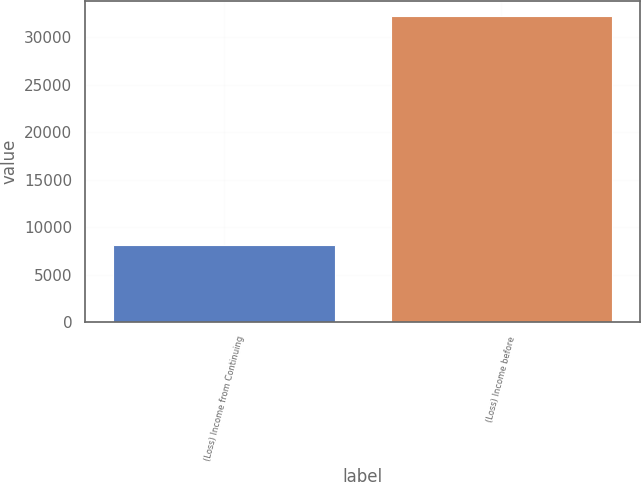Convert chart to OTSL. <chart><loc_0><loc_0><loc_500><loc_500><bar_chart><fcel>(Loss) Income from Continuing<fcel>(Loss) Income before<nl><fcel>8131<fcel>32238<nl></chart> 